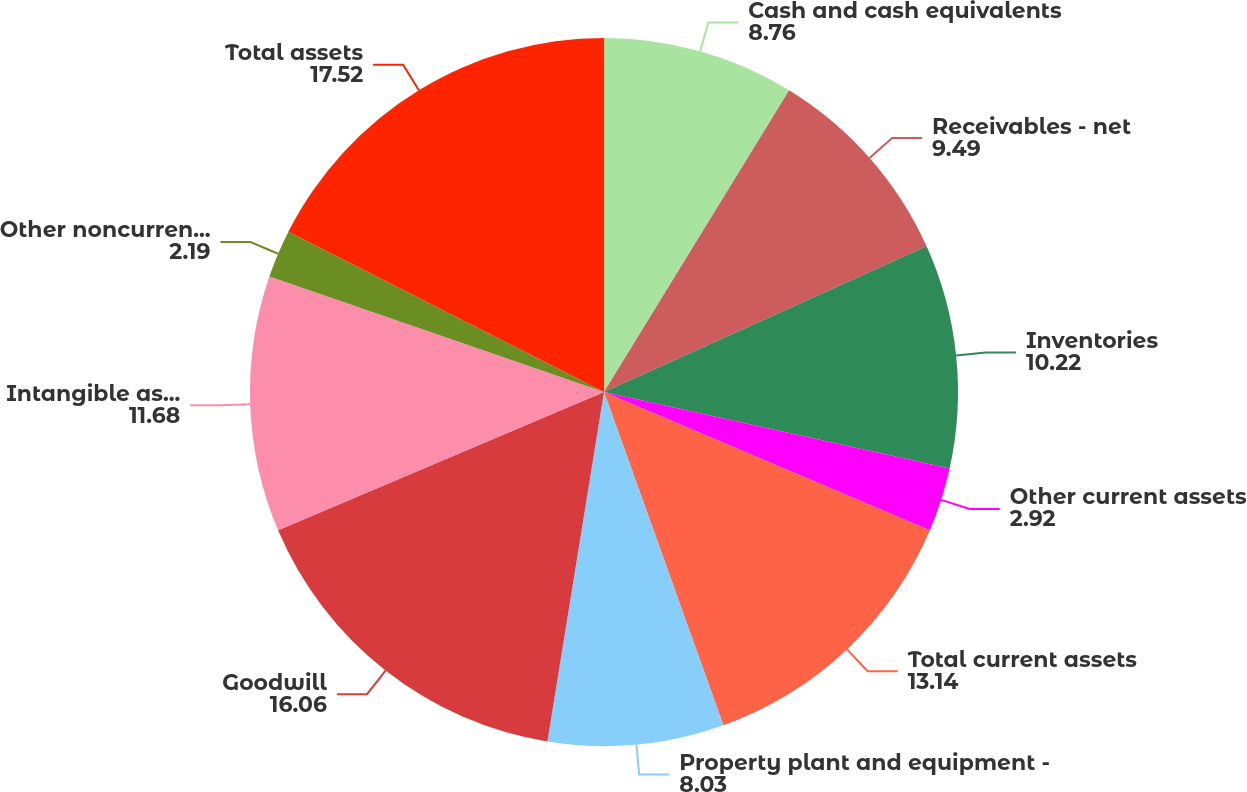<chart> <loc_0><loc_0><loc_500><loc_500><pie_chart><fcel>Cash and cash equivalents<fcel>Receivables - net<fcel>Inventories<fcel>Other current assets<fcel>Total current assets<fcel>Property plant and equipment -<fcel>Goodwill<fcel>Intangible assets - net<fcel>Other noncurrent assets<fcel>Total assets<nl><fcel>8.76%<fcel>9.49%<fcel>10.22%<fcel>2.92%<fcel>13.14%<fcel>8.03%<fcel>16.06%<fcel>11.68%<fcel>2.19%<fcel>17.52%<nl></chart> 